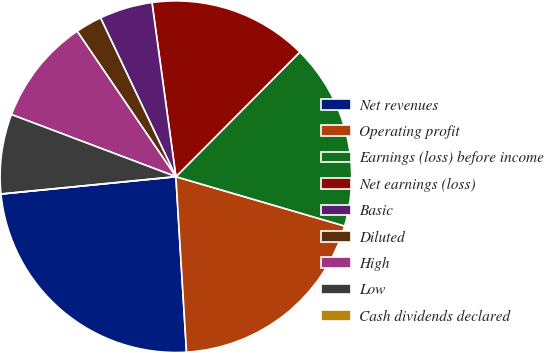Convert chart. <chart><loc_0><loc_0><loc_500><loc_500><pie_chart><fcel>Net revenues<fcel>Operating profit<fcel>Earnings (loss) before income<fcel>Net earnings (loss)<fcel>Basic<fcel>Diluted<fcel>High<fcel>Low<fcel>Cash dividends declared<nl><fcel>24.39%<fcel>19.51%<fcel>17.07%<fcel>14.63%<fcel>4.88%<fcel>2.44%<fcel>9.76%<fcel>7.32%<fcel>0.0%<nl></chart> 